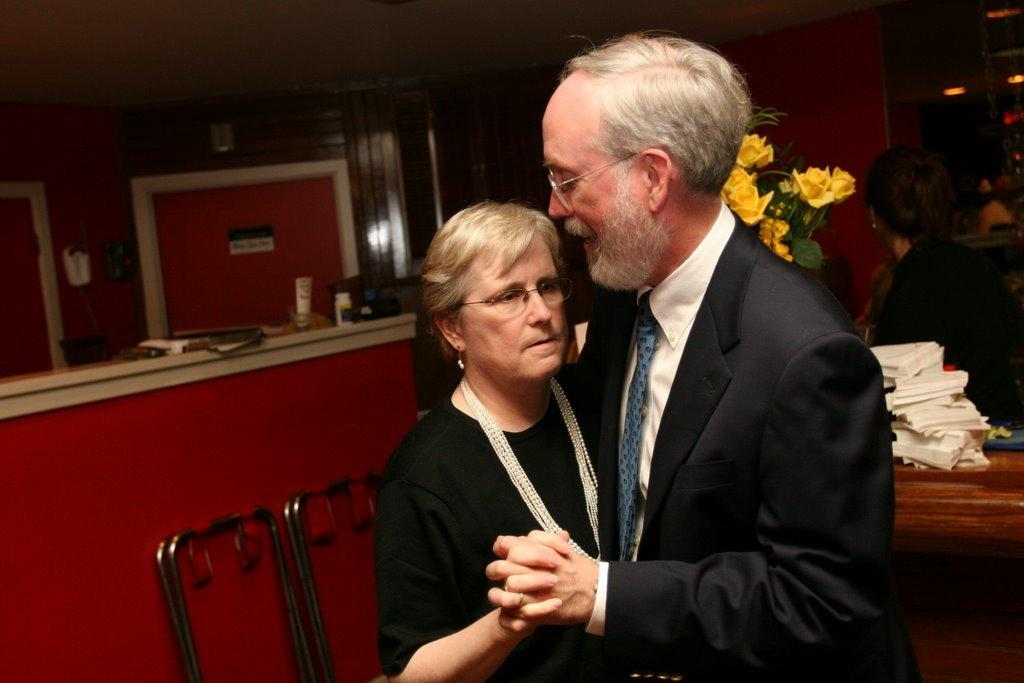How many people are in the image? There are two persons in the image. Can you describe the gender of the two persons? One of the persons is a man, and the other person is a woman. What can be seen in the background behind the two persons? There are flowers behind the two persons. Where are the tissues located in the image? The tissues are on the right side of the image. What scene does the visitor hope to see in the image? There is no visitor present in the image, so it is not possible to determine what scene they might hope to see. 